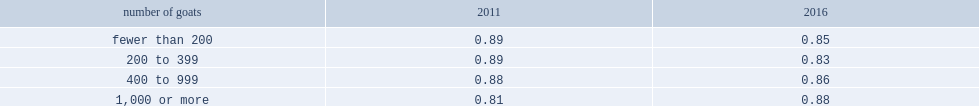What is the ratio for agricultural operations in ontario as a whole in 2016? 0.855. 